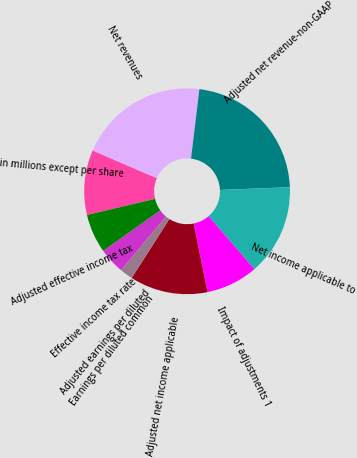Convert chart to OTSL. <chart><loc_0><loc_0><loc_500><loc_500><pie_chart><fcel>in millions except per share<fcel>Net revenues<fcel>Adjusted net revenue-non-GAAP<fcel>Net income applicable to<fcel>Impact of adjustments 1<fcel>Adjusted net income applicable<fcel>Earnings per diluted common<fcel>Adjusted earnings per diluted<fcel>Effective income tax rate<fcel>Adjusted effective income tax<nl><fcel>10.2%<fcel>20.41%<fcel>22.45%<fcel>14.28%<fcel>8.16%<fcel>12.24%<fcel>2.04%<fcel>0.0%<fcel>4.08%<fcel>6.12%<nl></chart> 